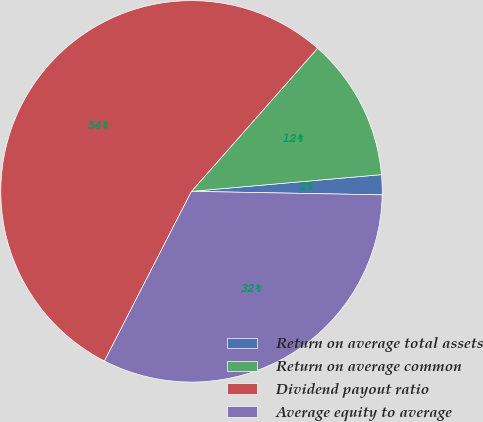Convert chart to OTSL. <chart><loc_0><loc_0><loc_500><loc_500><pie_chart><fcel>Return on average total assets<fcel>Return on average common<fcel>Dividend payout ratio<fcel>Average equity to average<nl><fcel>1.69%<fcel>12.11%<fcel>53.95%<fcel>32.25%<nl></chart> 